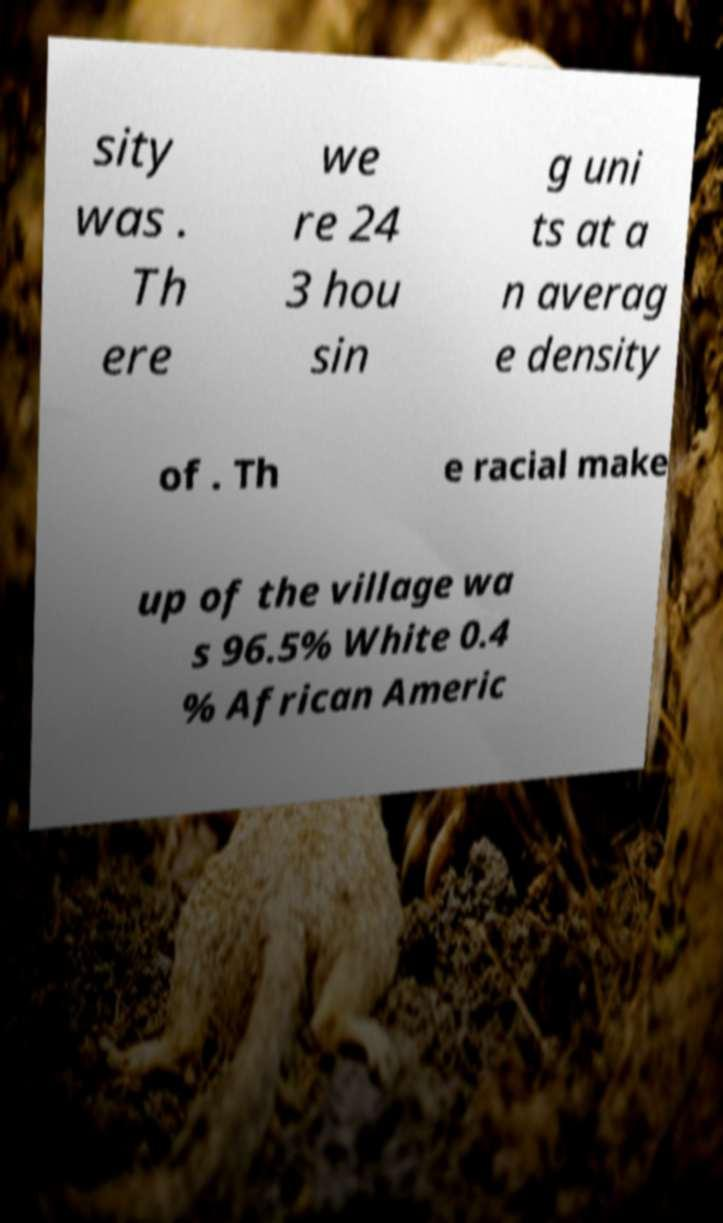Could you assist in decoding the text presented in this image and type it out clearly? sity was . Th ere we re 24 3 hou sin g uni ts at a n averag e density of . Th e racial make up of the village wa s 96.5% White 0.4 % African Americ 